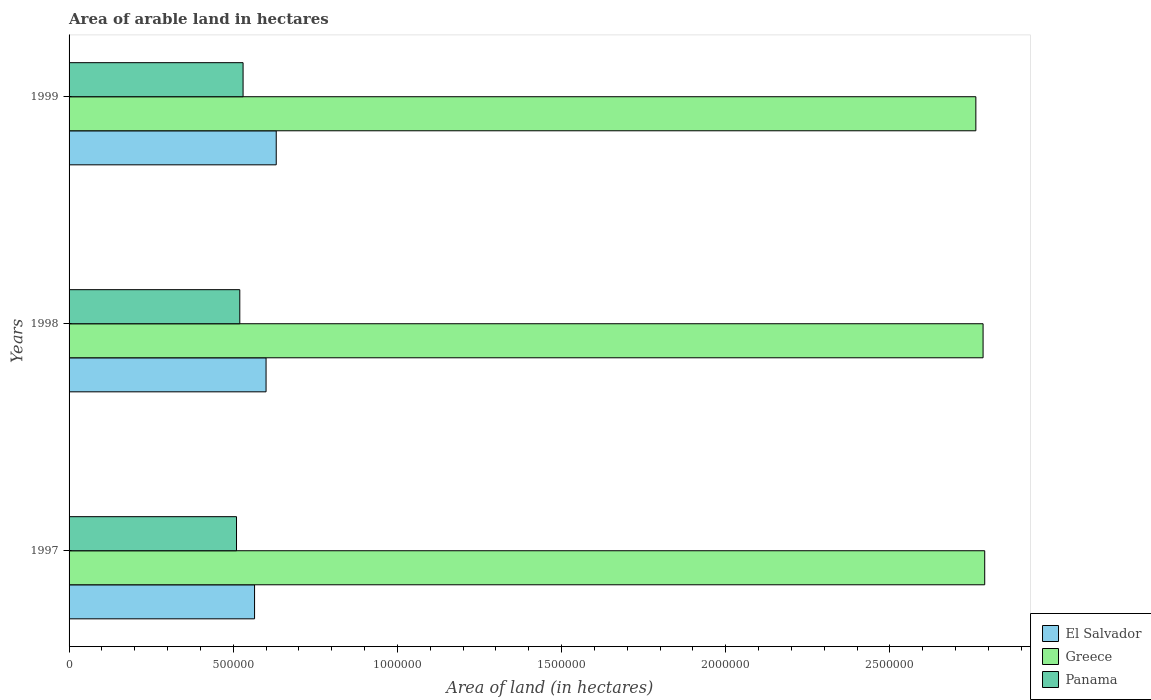How many different coloured bars are there?
Ensure brevity in your answer.  3. How many bars are there on the 1st tick from the bottom?
Make the answer very short. 3. What is the label of the 1st group of bars from the top?
Provide a short and direct response. 1999. In how many cases, is the number of bars for a given year not equal to the number of legend labels?
Offer a very short reply. 0. What is the total arable land in Panama in 1999?
Ensure brevity in your answer.  5.30e+05. Across all years, what is the maximum total arable land in Greece?
Offer a very short reply. 2.79e+06. Across all years, what is the minimum total arable land in Panama?
Your response must be concise. 5.10e+05. In which year was the total arable land in Greece maximum?
Give a very brief answer. 1997. In which year was the total arable land in Greece minimum?
Make the answer very short. 1999. What is the total total arable land in Panama in the graph?
Your answer should be compact. 1.56e+06. What is the difference between the total arable land in Panama in 1997 and that in 1999?
Your answer should be compact. -2.00e+04. What is the difference between the total arable land in El Salvador in 1998 and the total arable land in Panama in 1999?
Ensure brevity in your answer.  7.00e+04. What is the average total arable land in El Salvador per year?
Provide a short and direct response. 5.99e+05. In the year 1999, what is the difference between the total arable land in Greece and total arable land in El Salvador?
Provide a succinct answer. 2.13e+06. In how many years, is the total arable land in El Salvador greater than 2700000 hectares?
Your answer should be compact. 0. What is the ratio of the total arable land in Greece in 1997 to that in 1999?
Ensure brevity in your answer.  1.01. Is the total arable land in El Salvador in 1997 less than that in 1998?
Ensure brevity in your answer.  Yes. Is the difference between the total arable land in Greece in 1998 and 1999 greater than the difference between the total arable land in El Salvador in 1998 and 1999?
Make the answer very short. Yes. What is the difference between the highest and the lowest total arable land in Panama?
Your response must be concise. 2.00e+04. Is the sum of the total arable land in Panama in 1997 and 1999 greater than the maximum total arable land in El Salvador across all years?
Provide a short and direct response. Yes. What does the 1st bar from the top in 1997 represents?
Keep it short and to the point. Panama. What does the 3rd bar from the bottom in 1999 represents?
Your answer should be very brief. Panama. How many bars are there?
Make the answer very short. 9. How many years are there in the graph?
Ensure brevity in your answer.  3. What is the difference between two consecutive major ticks on the X-axis?
Ensure brevity in your answer.  5.00e+05. Does the graph contain grids?
Your answer should be very brief. No. How many legend labels are there?
Your answer should be compact. 3. What is the title of the graph?
Your response must be concise. Area of arable land in hectares. Does "American Samoa" appear as one of the legend labels in the graph?
Your answer should be compact. No. What is the label or title of the X-axis?
Your answer should be compact. Area of land (in hectares). What is the Area of land (in hectares) in El Salvador in 1997?
Keep it short and to the point. 5.65e+05. What is the Area of land (in hectares) in Greece in 1997?
Keep it short and to the point. 2.79e+06. What is the Area of land (in hectares) of Panama in 1997?
Keep it short and to the point. 5.10e+05. What is the Area of land (in hectares) in El Salvador in 1998?
Give a very brief answer. 6.00e+05. What is the Area of land (in hectares) in Greece in 1998?
Offer a very short reply. 2.78e+06. What is the Area of land (in hectares) of Panama in 1998?
Your answer should be very brief. 5.20e+05. What is the Area of land (in hectares) of El Salvador in 1999?
Provide a succinct answer. 6.31e+05. What is the Area of land (in hectares) of Greece in 1999?
Make the answer very short. 2.76e+06. What is the Area of land (in hectares) in Panama in 1999?
Your answer should be very brief. 5.30e+05. Across all years, what is the maximum Area of land (in hectares) of El Salvador?
Offer a terse response. 6.31e+05. Across all years, what is the maximum Area of land (in hectares) in Greece?
Your answer should be compact. 2.79e+06. Across all years, what is the maximum Area of land (in hectares) in Panama?
Give a very brief answer. 5.30e+05. Across all years, what is the minimum Area of land (in hectares) of El Salvador?
Your answer should be very brief. 5.65e+05. Across all years, what is the minimum Area of land (in hectares) of Greece?
Offer a terse response. 2.76e+06. Across all years, what is the minimum Area of land (in hectares) of Panama?
Make the answer very short. 5.10e+05. What is the total Area of land (in hectares) of El Salvador in the graph?
Offer a very short reply. 1.80e+06. What is the total Area of land (in hectares) in Greece in the graph?
Offer a terse response. 8.34e+06. What is the total Area of land (in hectares) in Panama in the graph?
Offer a very short reply. 1.56e+06. What is the difference between the Area of land (in hectares) of El Salvador in 1997 and that in 1998?
Your answer should be very brief. -3.50e+04. What is the difference between the Area of land (in hectares) of El Salvador in 1997 and that in 1999?
Your answer should be compact. -6.60e+04. What is the difference between the Area of land (in hectares) in Greece in 1997 and that in 1999?
Offer a very short reply. 2.70e+04. What is the difference between the Area of land (in hectares) in El Salvador in 1998 and that in 1999?
Your answer should be very brief. -3.10e+04. What is the difference between the Area of land (in hectares) of Greece in 1998 and that in 1999?
Offer a terse response. 2.20e+04. What is the difference between the Area of land (in hectares) of Panama in 1998 and that in 1999?
Offer a very short reply. -10000. What is the difference between the Area of land (in hectares) in El Salvador in 1997 and the Area of land (in hectares) in Greece in 1998?
Give a very brief answer. -2.22e+06. What is the difference between the Area of land (in hectares) in El Salvador in 1997 and the Area of land (in hectares) in Panama in 1998?
Provide a succinct answer. 4.50e+04. What is the difference between the Area of land (in hectares) in Greece in 1997 and the Area of land (in hectares) in Panama in 1998?
Make the answer very short. 2.27e+06. What is the difference between the Area of land (in hectares) in El Salvador in 1997 and the Area of land (in hectares) in Greece in 1999?
Keep it short and to the point. -2.20e+06. What is the difference between the Area of land (in hectares) in El Salvador in 1997 and the Area of land (in hectares) in Panama in 1999?
Give a very brief answer. 3.50e+04. What is the difference between the Area of land (in hectares) of Greece in 1997 and the Area of land (in hectares) of Panama in 1999?
Make the answer very short. 2.26e+06. What is the difference between the Area of land (in hectares) of El Salvador in 1998 and the Area of land (in hectares) of Greece in 1999?
Offer a very short reply. -2.16e+06. What is the difference between the Area of land (in hectares) in El Salvador in 1998 and the Area of land (in hectares) in Panama in 1999?
Give a very brief answer. 7.00e+04. What is the difference between the Area of land (in hectares) in Greece in 1998 and the Area of land (in hectares) in Panama in 1999?
Your answer should be very brief. 2.25e+06. What is the average Area of land (in hectares) of El Salvador per year?
Offer a terse response. 5.99e+05. What is the average Area of land (in hectares) of Greece per year?
Your answer should be very brief. 2.78e+06. What is the average Area of land (in hectares) of Panama per year?
Keep it short and to the point. 5.20e+05. In the year 1997, what is the difference between the Area of land (in hectares) in El Salvador and Area of land (in hectares) in Greece?
Your answer should be very brief. -2.22e+06. In the year 1997, what is the difference between the Area of land (in hectares) in El Salvador and Area of land (in hectares) in Panama?
Offer a very short reply. 5.50e+04. In the year 1997, what is the difference between the Area of land (in hectares) of Greece and Area of land (in hectares) of Panama?
Offer a very short reply. 2.28e+06. In the year 1998, what is the difference between the Area of land (in hectares) in El Salvador and Area of land (in hectares) in Greece?
Provide a short and direct response. -2.18e+06. In the year 1998, what is the difference between the Area of land (in hectares) of El Salvador and Area of land (in hectares) of Panama?
Your answer should be very brief. 8.00e+04. In the year 1998, what is the difference between the Area of land (in hectares) of Greece and Area of land (in hectares) of Panama?
Offer a terse response. 2.26e+06. In the year 1999, what is the difference between the Area of land (in hectares) in El Salvador and Area of land (in hectares) in Greece?
Offer a very short reply. -2.13e+06. In the year 1999, what is the difference between the Area of land (in hectares) in El Salvador and Area of land (in hectares) in Panama?
Ensure brevity in your answer.  1.01e+05. In the year 1999, what is the difference between the Area of land (in hectares) of Greece and Area of land (in hectares) of Panama?
Your answer should be very brief. 2.23e+06. What is the ratio of the Area of land (in hectares) in El Salvador in 1997 to that in 1998?
Your response must be concise. 0.94. What is the ratio of the Area of land (in hectares) in Panama in 1997 to that in 1998?
Your answer should be compact. 0.98. What is the ratio of the Area of land (in hectares) in El Salvador in 1997 to that in 1999?
Your answer should be very brief. 0.9. What is the ratio of the Area of land (in hectares) of Greece in 1997 to that in 1999?
Make the answer very short. 1.01. What is the ratio of the Area of land (in hectares) of Panama in 1997 to that in 1999?
Provide a succinct answer. 0.96. What is the ratio of the Area of land (in hectares) in El Salvador in 1998 to that in 1999?
Your answer should be very brief. 0.95. What is the ratio of the Area of land (in hectares) in Greece in 1998 to that in 1999?
Make the answer very short. 1.01. What is the ratio of the Area of land (in hectares) of Panama in 1998 to that in 1999?
Offer a terse response. 0.98. What is the difference between the highest and the second highest Area of land (in hectares) of El Salvador?
Your response must be concise. 3.10e+04. What is the difference between the highest and the second highest Area of land (in hectares) of Panama?
Ensure brevity in your answer.  10000. What is the difference between the highest and the lowest Area of land (in hectares) of El Salvador?
Your response must be concise. 6.60e+04. What is the difference between the highest and the lowest Area of land (in hectares) of Greece?
Your answer should be compact. 2.70e+04. What is the difference between the highest and the lowest Area of land (in hectares) in Panama?
Your answer should be very brief. 2.00e+04. 